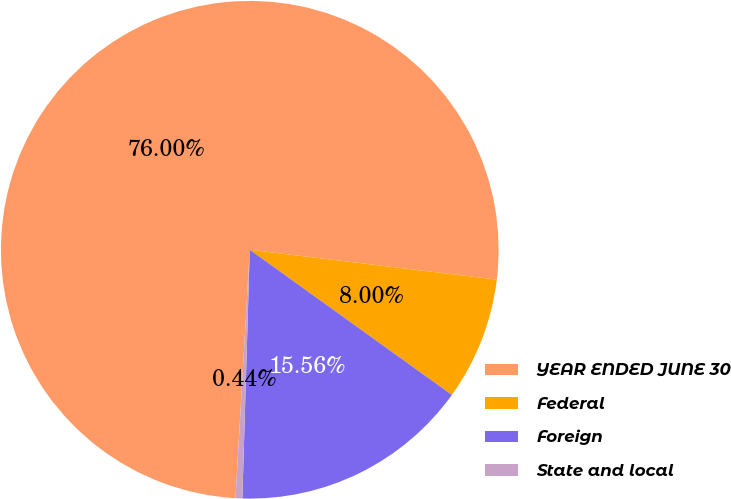Convert chart. <chart><loc_0><loc_0><loc_500><loc_500><pie_chart><fcel>YEAR ENDED JUNE 30<fcel>Federal<fcel>Foreign<fcel>State and local<nl><fcel>76.0%<fcel>8.0%<fcel>15.56%<fcel>0.44%<nl></chart> 